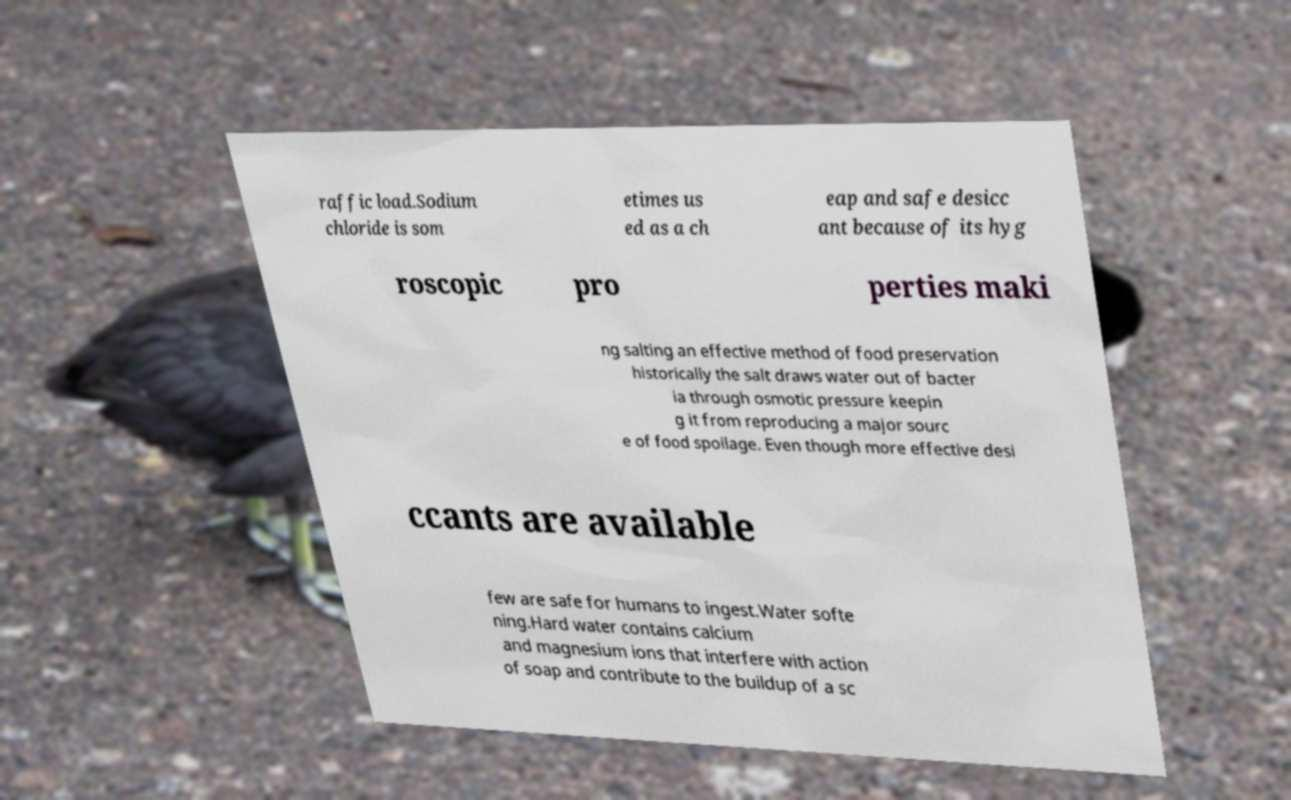What messages or text are displayed in this image? I need them in a readable, typed format. raffic load.Sodium chloride is som etimes us ed as a ch eap and safe desicc ant because of its hyg roscopic pro perties maki ng salting an effective method of food preservation historically the salt draws water out of bacter ia through osmotic pressure keepin g it from reproducing a major sourc e of food spoilage. Even though more effective desi ccants are available few are safe for humans to ingest.Water softe ning.Hard water contains calcium and magnesium ions that interfere with action of soap and contribute to the buildup of a sc 